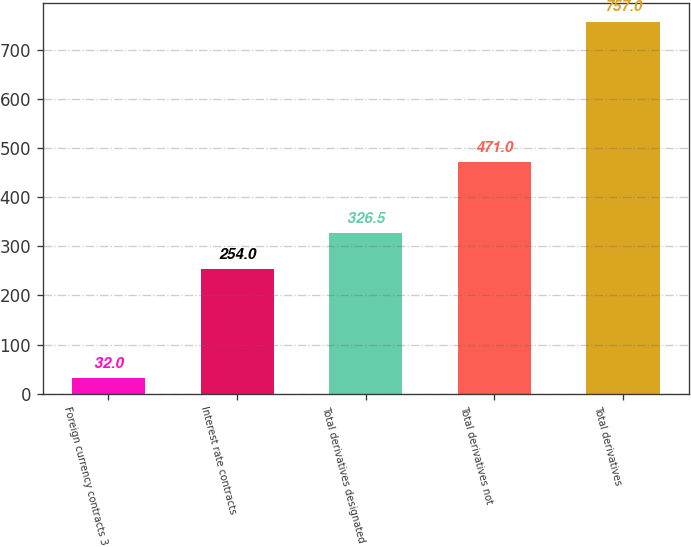<chart> <loc_0><loc_0><loc_500><loc_500><bar_chart><fcel>Foreign currency contracts 3<fcel>Interest rate contracts<fcel>Total derivatives designated<fcel>Total derivatives not<fcel>Total derivatives<nl><fcel>32<fcel>254<fcel>326.5<fcel>471<fcel>757<nl></chart> 